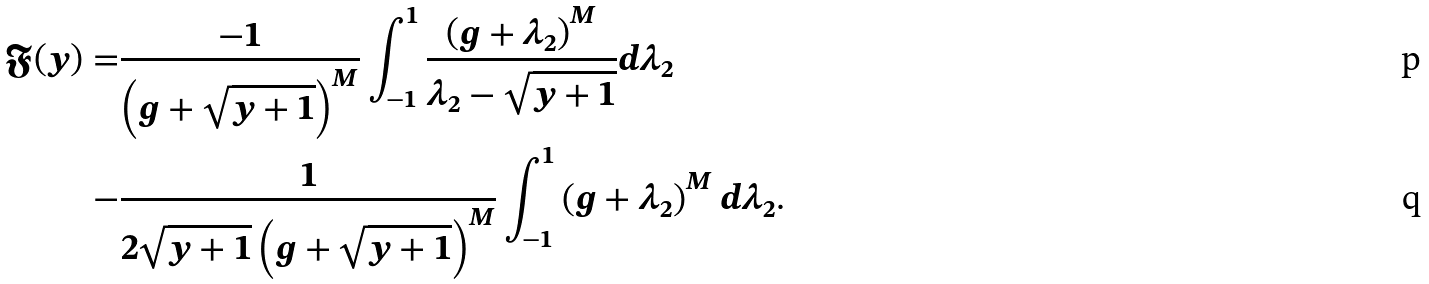<formula> <loc_0><loc_0><loc_500><loc_500>\mathfrak { F } ( y ) = & \frac { - 1 } { \left ( g + \sqrt { y + 1 } \right ) ^ { M } } \int _ { - 1 } ^ { 1 } \frac { \left ( g + \lambda _ { 2 } \right ) ^ { M } } { \lambda _ { 2 } - \sqrt { y + 1 } } d \lambda _ { 2 } \\ - & \frac { 1 } { 2 \sqrt { y + 1 } \left ( g + \sqrt { y + 1 } \right ) ^ { M } } \int _ { - 1 } ^ { 1 } \left ( g + \lambda _ { 2 } \right ) ^ { M } d \lambda _ { 2 } .</formula> 